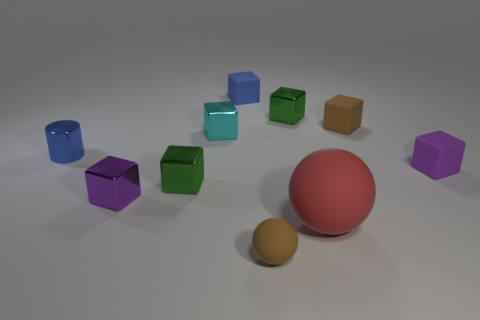Subtract all tiny brown rubber blocks. How many blocks are left? 6 Subtract all purple cubes. How many cubes are left? 5 Subtract all red cubes. Subtract all purple spheres. How many cubes are left? 7 Subtract all balls. How many objects are left? 8 Add 3 shiny cylinders. How many shiny cylinders are left? 4 Add 2 tiny blocks. How many tiny blocks exist? 9 Subtract 0 gray cubes. How many objects are left? 10 Subtract all green metal cylinders. Subtract all cylinders. How many objects are left? 9 